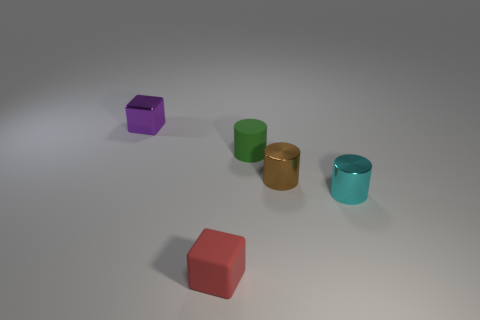Is there anything else that has the same size as the brown metallic object?
Give a very brief answer. Yes. Is the number of small red rubber things greater than the number of cyan metallic balls?
Your answer should be very brief. Yes. What is the size of the object that is both behind the tiny cyan cylinder and left of the tiny green rubber cylinder?
Your answer should be compact. Small. What is the shape of the purple metal object?
Offer a terse response. Cube. What number of cyan metallic objects have the same shape as the small purple thing?
Your answer should be compact. 0. Is the number of red blocks in front of the small red object less than the number of tiny green cylinders that are in front of the rubber cylinder?
Offer a very short reply. No. There is a block behind the cyan metal cylinder; how many brown metal objects are behind it?
Your answer should be very brief. 0. Are there any brown metal cylinders?
Keep it short and to the point. Yes. Are there any green cylinders that have the same material as the green thing?
Your response must be concise. No. Are there more small blocks that are on the left side of the small matte block than purple metal cubes that are on the left side of the tiny purple block?
Provide a short and direct response. Yes. 